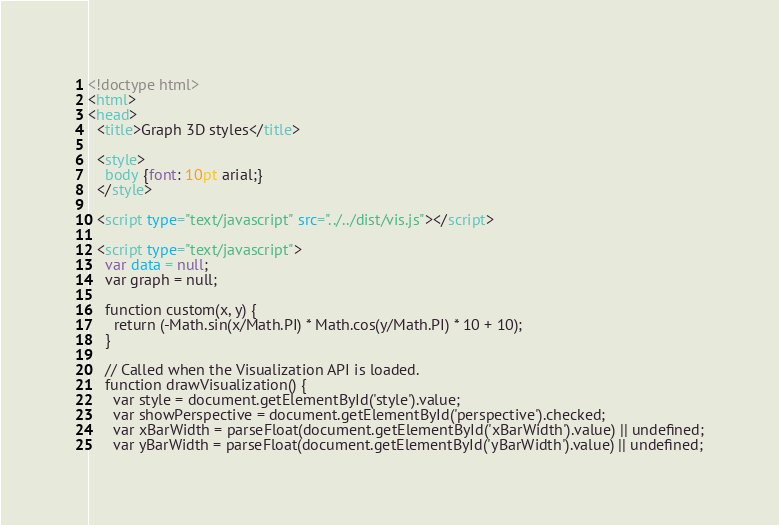<code> <loc_0><loc_0><loc_500><loc_500><_HTML_><!doctype html>
<html>
<head>
  <title>Graph 3D styles</title>

  <style>
    body {font: 10pt arial;}
  </style>

  <script type="text/javascript" src="../../dist/vis.js"></script>

  <script type="text/javascript">
    var data = null;
    var graph = null;

    function custom(x, y) {
      return (-Math.sin(x/Math.PI) * Math.cos(y/Math.PI) * 10 + 10);
    }

    // Called when the Visualization API is loaded.
    function drawVisualization() {
      var style = document.getElementById('style').value;
      var showPerspective = document.getElementById('perspective').checked;
      var xBarWidth = parseFloat(document.getElementById('xBarWidth').value) || undefined;
      var yBarWidth = parseFloat(document.getElementById('yBarWidth').value) || undefined;</code> 